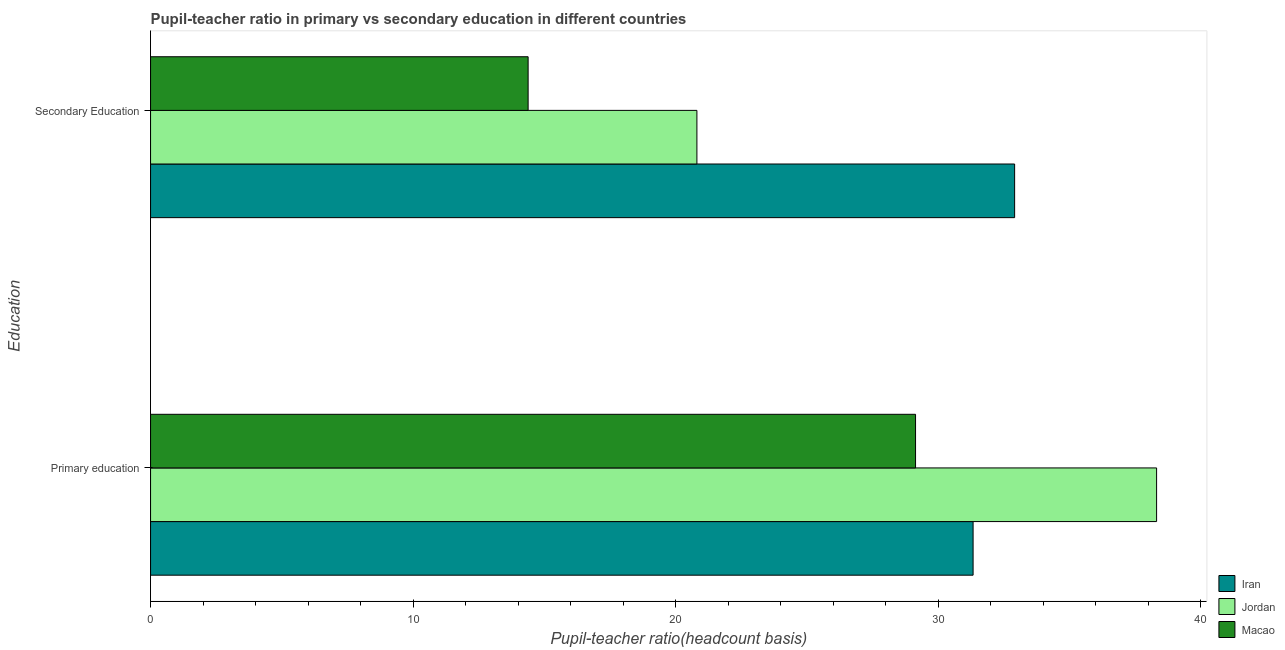How many groups of bars are there?
Offer a very short reply. 2. Are the number of bars per tick equal to the number of legend labels?
Make the answer very short. Yes. What is the label of the 2nd group of bars from the top?
Provide a succinct answer. Primary education. What is the pupil teacher ratio on secondary education in Jordan?
Provide a short and direct response. 20.81. Across all countries, what is the maximum pupil teacher ratio on secondary education?
Offer a very short reply. 32.91. Across all countries, what is the minimum pupil teacher ratio on secondary education?
Make the answer very short. 14.38. In which country was the pupil teacher ratio on secondary education maximum?
Offer a terse response. Iran. In which country was the pupil teacher ratio on secondary education minimum?
Your answer should be compact. Macao. What is the total pupil-teacher ratio in primary education in the graph?
Your answer should be compact. 98.78. What is the difference between the pupil-teacher ratio in primary education in Macao and that in Iran?
Keep it short and to the point. -2.19. What is the difference between the pupil teacher ratio on secondary education in Macao and the pupil-teacher ratio in primary education in Iran?
Offer a terse response. -16.95. What is the average pupil-teacher ratio in primary education per country?
Provide a succinct answer. 32.93. What is the difference between the pupil-teacher ratio in primary education and pupil teacher ratio on secondary education in Jordan?
Ensure brevity in your answer.  17.51. In how many countries, is the pupil teacher ratio on secondary education greater than 32 ?
Give a very brief answer. 1. What is the ratio of the pupil-teacher ratio in primary education in Jordan to that in Iran?
Your answer should be compact. 1.22. Is the pupil teacher ratio on secondary education in Jordan less than that in Macao?
Offer a very short reply. No. In how many countries, is the pupil-teacher ratio in primary education greater than the average pupil-teacher ratio in primary education taken over all countries?
Offer a very short reply. 1. What does the 3rd bar from the top in Primary education represents?
Keep it short and to the point. Iran. What does the 3rd bar from the bottom in Secondary Education represents?
Offer a very short reply. Macao. How many bars are there?
Your answer should be very brief. 6. Are all the bars in the graph horizontal?
Your answer should be very brief. Yes. How are the legend labels stacked?
Keep it short and to the point. Vertical. What is the title of the graph?
Offer a very short reply. Pupil-teacher ratio in primary vs secondary education in different countries. What is the label or title of the X-axis?
Make the answer very short. Pupil-teacher ratio(headcount basis). What is the label or title of the Y-axis?
Provide a succinct answer. Education. What is the Pupil-teacher ratio(headcount basis) of Iran in Primary education?
Offer a terse response. 31.33. What is the Pupil-teacher ratio(headcount basis) of Jordan in Primary education?
Your answer should be very brief. 38.32. What is the Pupil-teacher ratio(headcount basis) in Macao in Primary education?
Make the answer very short. 29.14. What is the Pupil-teacher ratio(headcount basis) in Iran in Secondary Education?
Ensure brevity in your answer.  32.91. What is the Pupil-teacher ratio(headcount basis) of Jordan in Secondary Education?
Give a very brief answer. 20.81. What is the Pupil-teacher ratio(headcount basis) in Macao in Secondary Education?
Provide a short and direct response. 14.38. Across all Education, what is the maximum Pupil-teacher ratio(headcount basis) in Iran?
Provide a short and direct response. 32.91. Across all Education, what is the maximum Pupil-teacher ratio(headcount basis) of Jordan?
Your response must be concise. 38.32. Across all Education, what is the maximum Pupil-teacher ratio(headcount basis) in Macao?
Your response must be concise. 29.14. Across all Education, what is the minimum Pupil-teacher ratio(headcount basis) of Iran?
Your answer should be very brief. 31.33. Across all Education, what is the minimum Pupil-teacher ratio(headcount basis) of Jordan?
Make the answer very short. 20.81. Across all Education, what is the minimum Pupil-teacher ratio(headcount basis) in Macao?
Your answer should be compact. 14.38. What is the total Pupil-teacher ratio(headcount basis) of Iran in the graph?
Make the answer very short. 64.24. What is the total Pupil-teacher ratio(headcount basis) in Jordan in the graph?
Provide a succinct answer. 59.13. What is the total Pupil-teacher ratio(headcount basis) of Macao in the graph?
Give a very brief answer. 43.52. What is the difference between the Pupil-teacher ratio(headcount basis) of Iran in Primary education and that in Secondary Education?
Give a very brief answer. -1.58. What is the difference between the Pupil-teacher ratio(headcount basis) in Jordan in Primary education and that in Secondary Education?
Make the answer very short. 17.51. What is the difference between the Pupil-teacher ratio(headcount basis) of Macao in Primary education and that in Secondary Education?
Your response must be concise. 14.76. What is the difference between the Pupil-teacher ratio(headcount basis) in Iran in Primary education and the Pupil-teacher ratio(headcount basis) in Jordan in Secondary Education?
Keep it short and to the point. 10.52. What is the difference between the Pupil-teacher ratio(headcount basis) of Iran in Primary education and the Pupil-teacher ratio(headcount basis) of Macao in Secondary Education?
Your response must be concise. 16.95. What is the difference between the Pupil-teacher ratio(headcount basis) of Jordan in Primary education and the Pupil-teacher ratio(headcount basis) of Macao in Secondary Education?
Give a very brief answer. 23.94. What is the average Pupil-teacher ratio(headcount basis) of Iran per Education?
Ensure brevity in your answer.  32.12. What is the average Pupil-teacher ratio(headcount basis) of Jordan per Education?
Provide a succinct answer. 29.56. What is the average Pupil-teacher ratio(headcount basis) of Macao per Education?
Ensure brevity in your answer.  21.76. What is the difference between the Pupil-teacher ratio(headcount basis) in Iran and Pupil-teacher ratio(headcount basis) in Jordan in Primary education?
Ensure brevity in your answer.  -6.99. What is the difference between the Pupil-teacher ratio(headcount basis) in Iran and Pupil-teacher ratio(headcount basis) in Macao in Primary education?
Provide a succinct answer. 2.19. What is the difference between the Pupil-teacher ratio(headcount basis) of Jordan and Pupil-teacher ratio(headcount basis) of Macao in Primary education?
Provide a short and direct response. 9.18. What is the difference between the Pupil-teacher ratio(headcount basis) of Iran and Pupil-teacher ratio(headcount basis) of Jordan in Secondary Education?
Provide a short and direct response. 12.1. What is the difference between the Pupil-teacher ratio(headcount basis) of Iran and Pupil-teacher ratio(headcount basis) of Macao in Secondary Education?
Offer a very short reply. 18.53. What is the difference between the Pupil-teacher ratio(headcount basis) in Jordan and Pupil-teacher ratio(headcount basis) in Macao in Secondary Education?
Offer a very short reply. 6.43. What is the ratio of the Pupil-teacher ratio(headcount basis) of Iran in Primary education to that in Secondary Education?
Offer a very short reply. 0.95. What is the ratio of the Pupil-teacher ratio(headcount basis) of Jordan in Primary education to that in Secondary Education?
Your answer should be compact. 1.84. What is the ratio of the Pupil-teacher ratio(headcount basis) of Macao in Primary education to that in Secondary Education?
Your answer should be very brief. 2.03. What is the difference between the highest and the second highest Pupil-teacher ratio(headcount basis) of Iran?
Your answer should be compact. 1.58. What is the difference between the highest and the second highest Pupil-teacher ratio(headcount basis) in Jordan?
Provide a succinct answer. 17.51. What is the difference between the highest and the second highest Pupil-teacher ratio(headcount basis) of Macao?
Give a very brief answer. 14.76. What is the difference between the highest and the lowest Pupil-teacher ratio(headcount basis) of Iran?
Your response must be concise. 1.58. What is the difference between the highest and the lowest Pupil-teacher ratio(headcount basis) in Jordan?
Provide a succinct answer. 17.51. What is the difference between the highest and the lowest Pupil-teacher ratio(headcount basis) in Macao?
Your response must be concise. 14.76. 